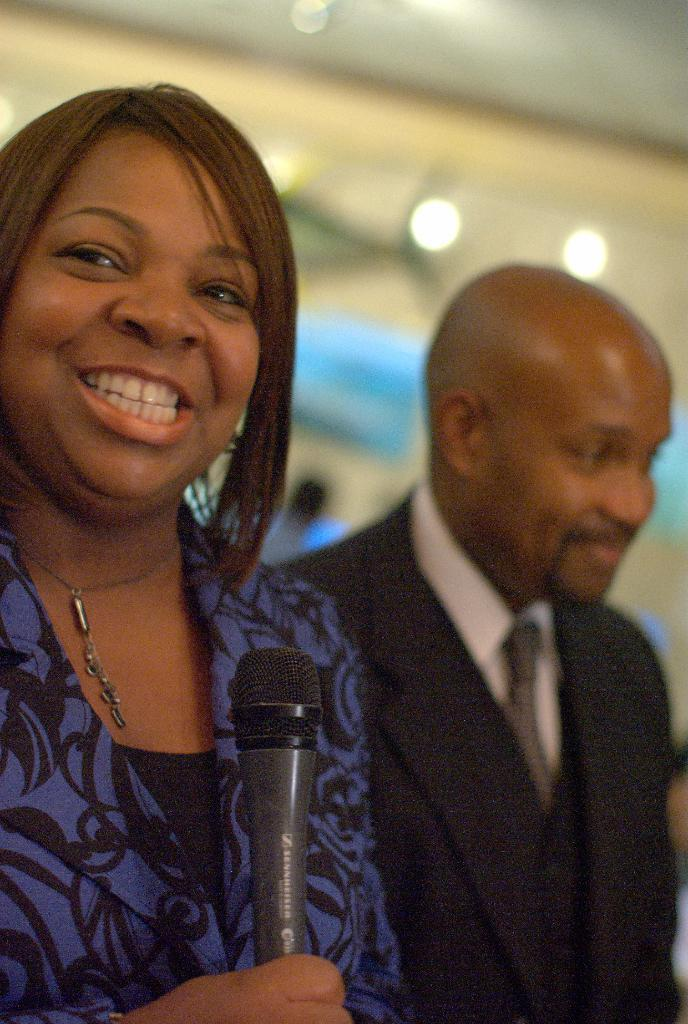Who is the main subject in the image? There is a woman in the image. What is the woman doing in the image? The woman is catching a microphone. Are there any other people in the image? Yes, there is another person in the image. What is the other person doing in the image? The other person is standing and smiling. What type of rake is the woman using to catch the microphone in the image? There is no rake present in the image; the woman is catching a microphone with her hands. 